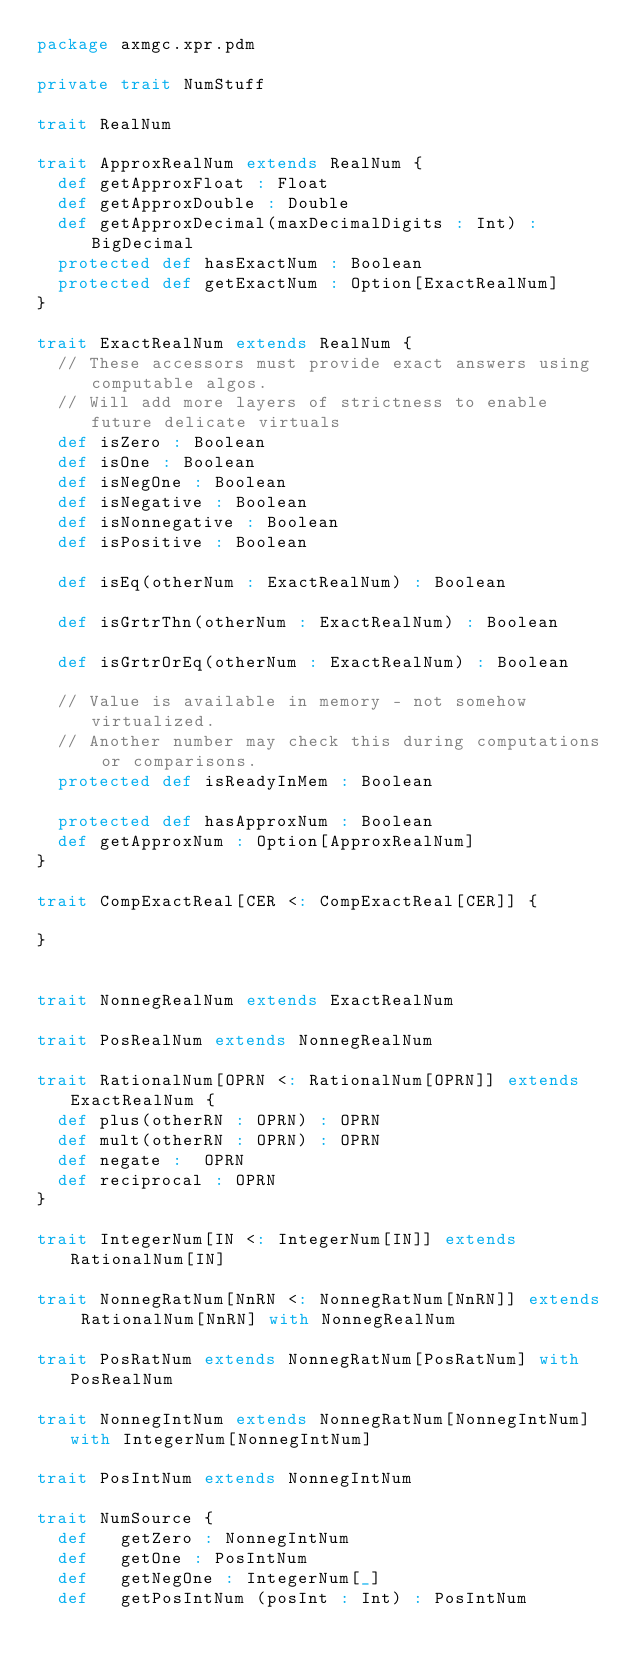<code> <loc_0><loc_0><loc_500><loc_500><_Scala_>package axmgc.xpr.pdm

private trait NumStuff

trait RealNum

trait ApproxRealNum extends RealNum {
	def getApproxFloat : Float
	def getApproxDouble : Double
	def getApproxDecimal(maxDecimalDigits : Int) : BigDecimal
	protected def hasExactNum : Boolean
	protected def getExactNum : Option[ExactRealNum]
}

trait ExactRealNum extends RealNum {
	// These accessors must provide exact answers using computable algos.
	// Will add more layers of strictness to enable future delicate virtuals
	def isZero : Boolean
	def isOne : Boolean
	def isNegOne : Boolean
	def isNegative : Boolean
	def isNonnegative : Boolean
	def isPositive : Boolean

	def isEq(otherNum : ExactRealNum) : Boolean

	def isGrtrThn(otherNum : ExactRealNum) : Boolean

	def isGrtrOrEq(otherNum : ExactRealNum) : Boolean

	// Value is available in memory - not somehow virtualized.
	// Another number may check this during computations or comparisons.
	protected def isReadyInMem : Boolean

	protected def hasApproxNum : Boolean
	def getApproxNum : Option[ApproxRealNum]
}

trait CompExactReal[CER <: CompExactReal[CER]] {

}


trait NonnegRealNum extends ExactRealNum

trait PosRealNum extends NonnegRealNum

trait RationalNum[OPRN <: RationalNum[OPRN]] extends ExactRealNum {
	def plus(otherRN : OPRN) : OPRN
	def mult(otherRN : OPRN) : OPRN
	def negate :  OPRN
	def reciprocal : OPRN
}

trait IntegerNum[IN <: IntegerNum[IN]] extends RationalNum[IN]

trait NonnegRatNum[NnRN <: NonnegRatNum[NnRN]] extends RationalNum[NnRN] with NonnegRealNum

trait PosRatNum extends NonnegRatNum[PosRatNum] with PosRealNum

trait NonnegIntNum extends NonnegRatNum[NonnegIntNum] with IntegerNum[NonnegIntNum]

trait PosIntNum extends NonnegIntNum

trait NumSource {
	def 	getZero	: NonnegIntNum
	def 	getOne : PosIntNum
	def 	getNegOne : IntegerNum[_]
	def 	getPosIntNum (posInt : Int) : PosIntNum</code> 